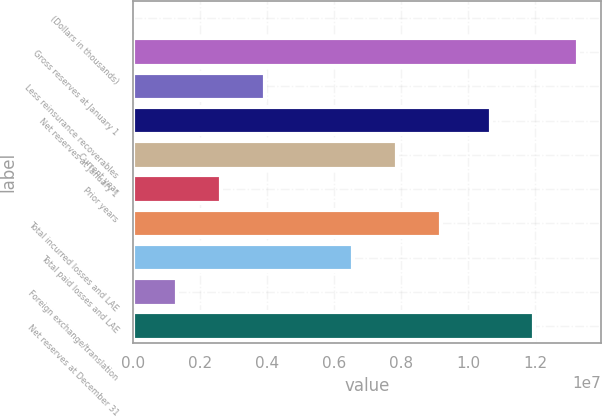Convert chart. <chart><loc_0><loc_0><loc_500><loc_500><bar_chart><fcel>(Dollars in thousands)<fcel>Gross reserves at January 1<fcel>Less reinsurance recoverables<fcel>Net reserves at January 1<fcel>Current year<fcel>Prior years<fcel>Total incurred losses and LAE<fcel>Total paid losses and LAE<fcel>Foreign exchange/translation<fcel>Net reserves at December 31<nl><fcel>2018<fcel>1.32951e+07<fcel>3.93714e+06<fcel>1.06717e+07<fcel>7.87226e+06<fcel>2.62543e+06<fcel>9.18397e+06<fcel>6.56055e+06<fcel>1.31373e+06<fcel>1.19834e+07<nl></chart> 